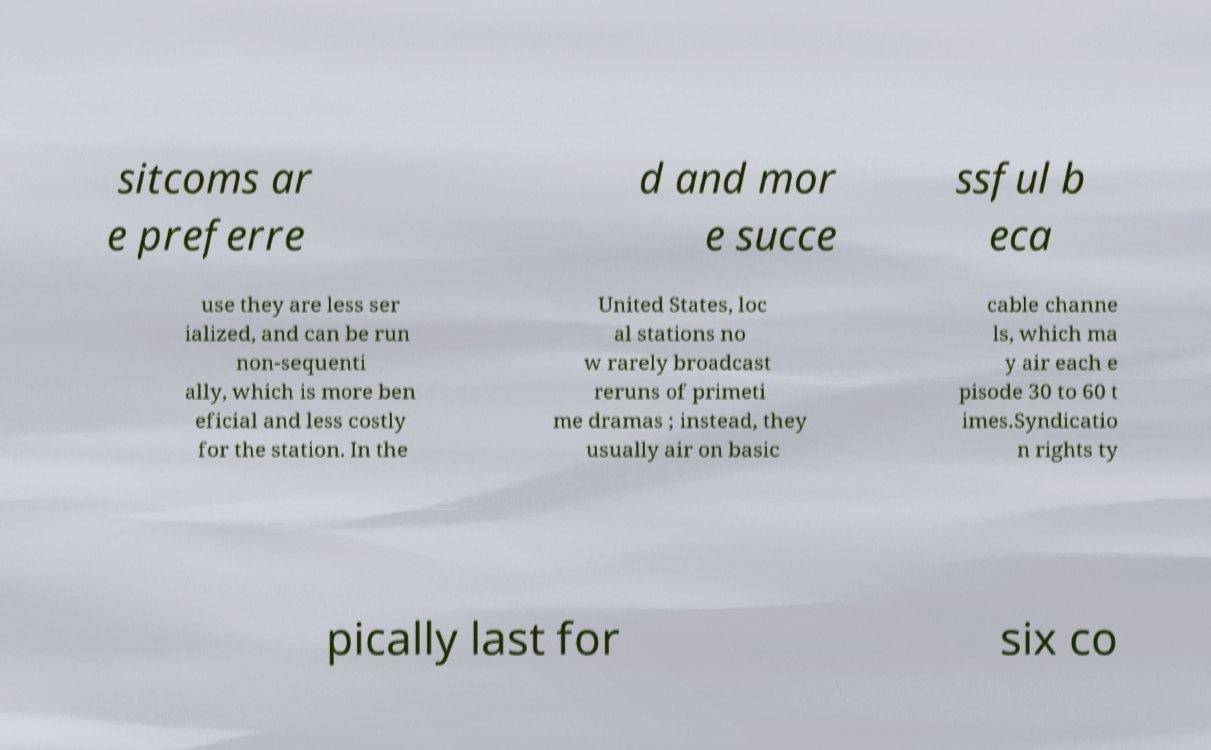Please read and relay the text visible in this image. What does it say? sitcoms ar e preferre d and mor e succe ssful b eca use they are less ser ialized, and can be run non-sequenti ally, which is more ben eficial and less costly for the station. In the United States, loc al stations no w rarely broadcast reruns of primeti me dramas ; instead, they usually air on basic cable channe ls, which ma y air each e pisode 30 to 60 t imes.Syndicatio n rights ty pically last for six co 